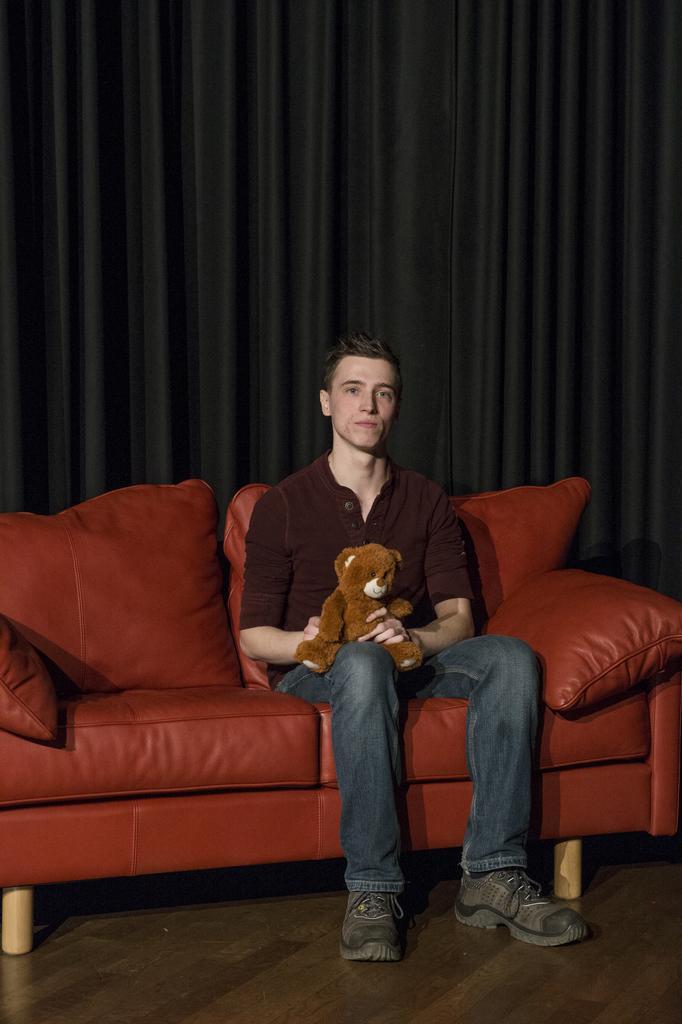Describe this image in one or two sentences. There is a person sitting on a sofa and he is holding a teddy bear in his hand. In the background we can see a black curtain. 